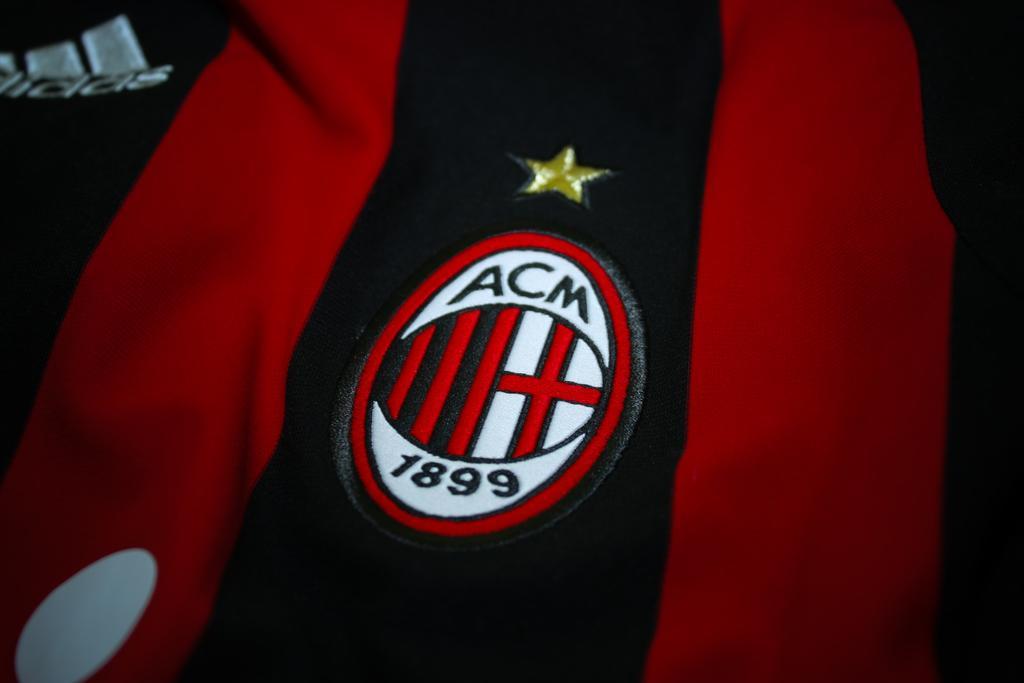Please provide a concise description of this image. In this image we can see a cloth with a logo and a star. 